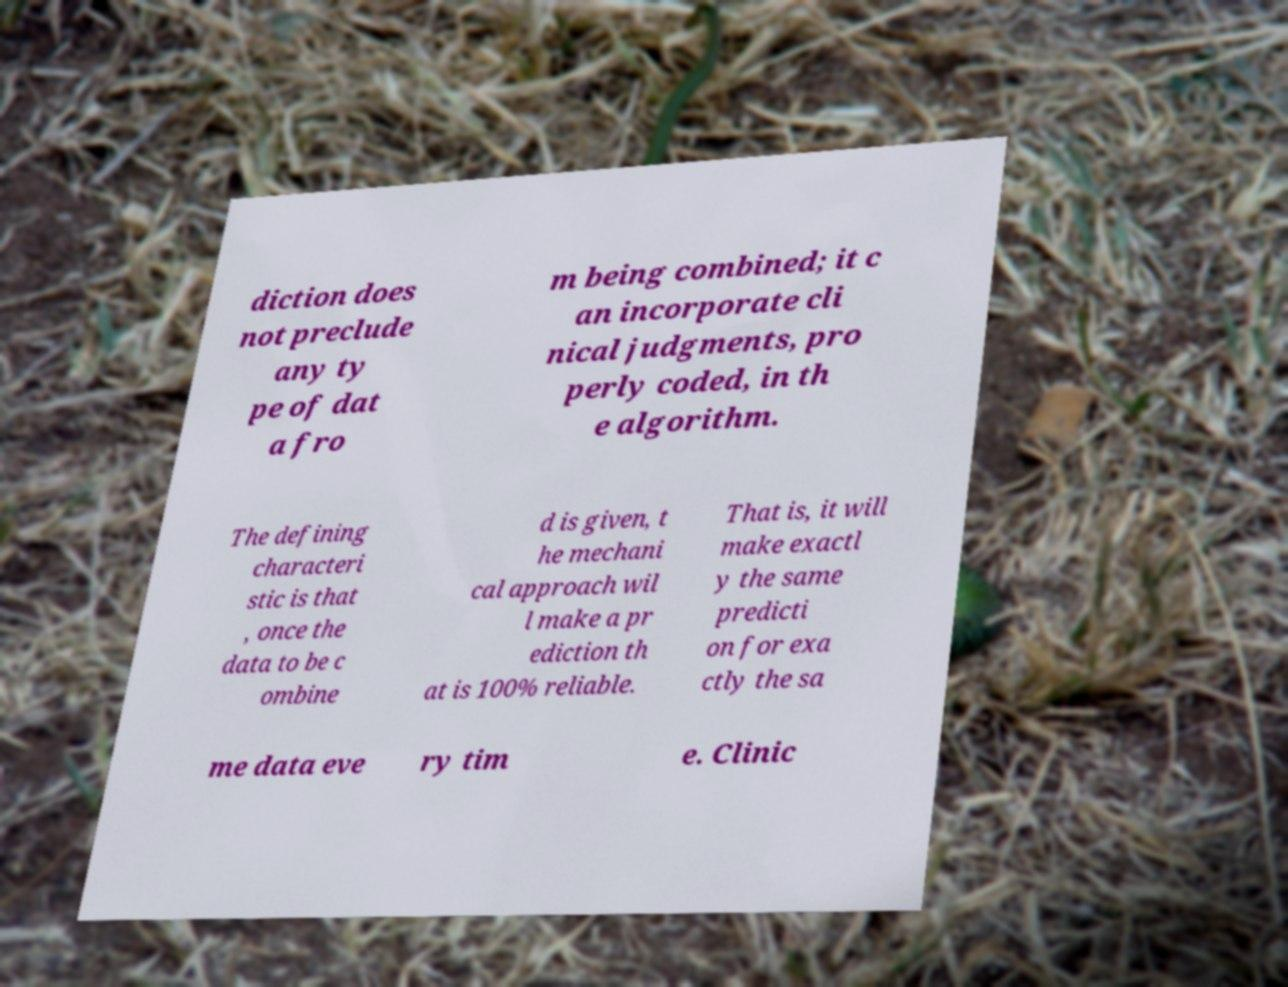Could you assist in decoding the text presented in this image and type it out clearly? diction does not preclude any ty pe of dat a fro m being combined; it c an incorporate cli nical judgments, pro perly coded, in th e algorithm. The defining characteri stic is that , once the data to be c ombine d is given, t he mechani cal approach wil l make a pr ediction th at is 100% reliable. That is, it will make exactl y the same predicti on for exa ctly the sa me data eve ry tim e. Clinic 